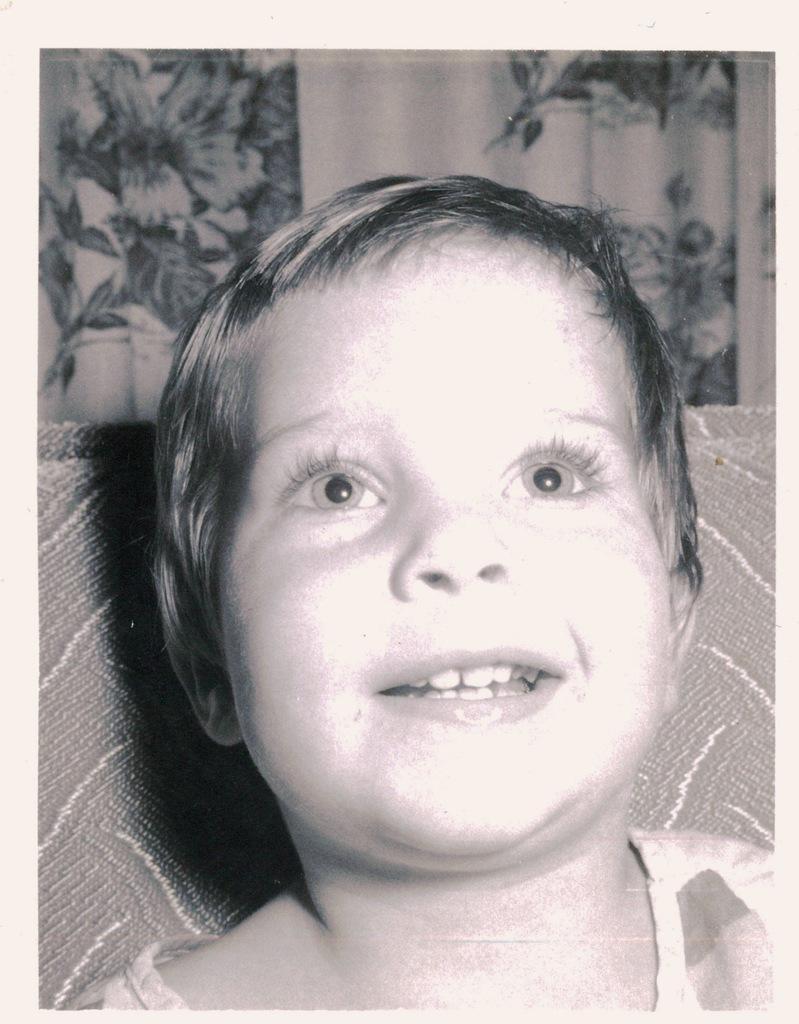Can you describe this image briefly? In this image we can see a kid. In the background there is a cloth. 